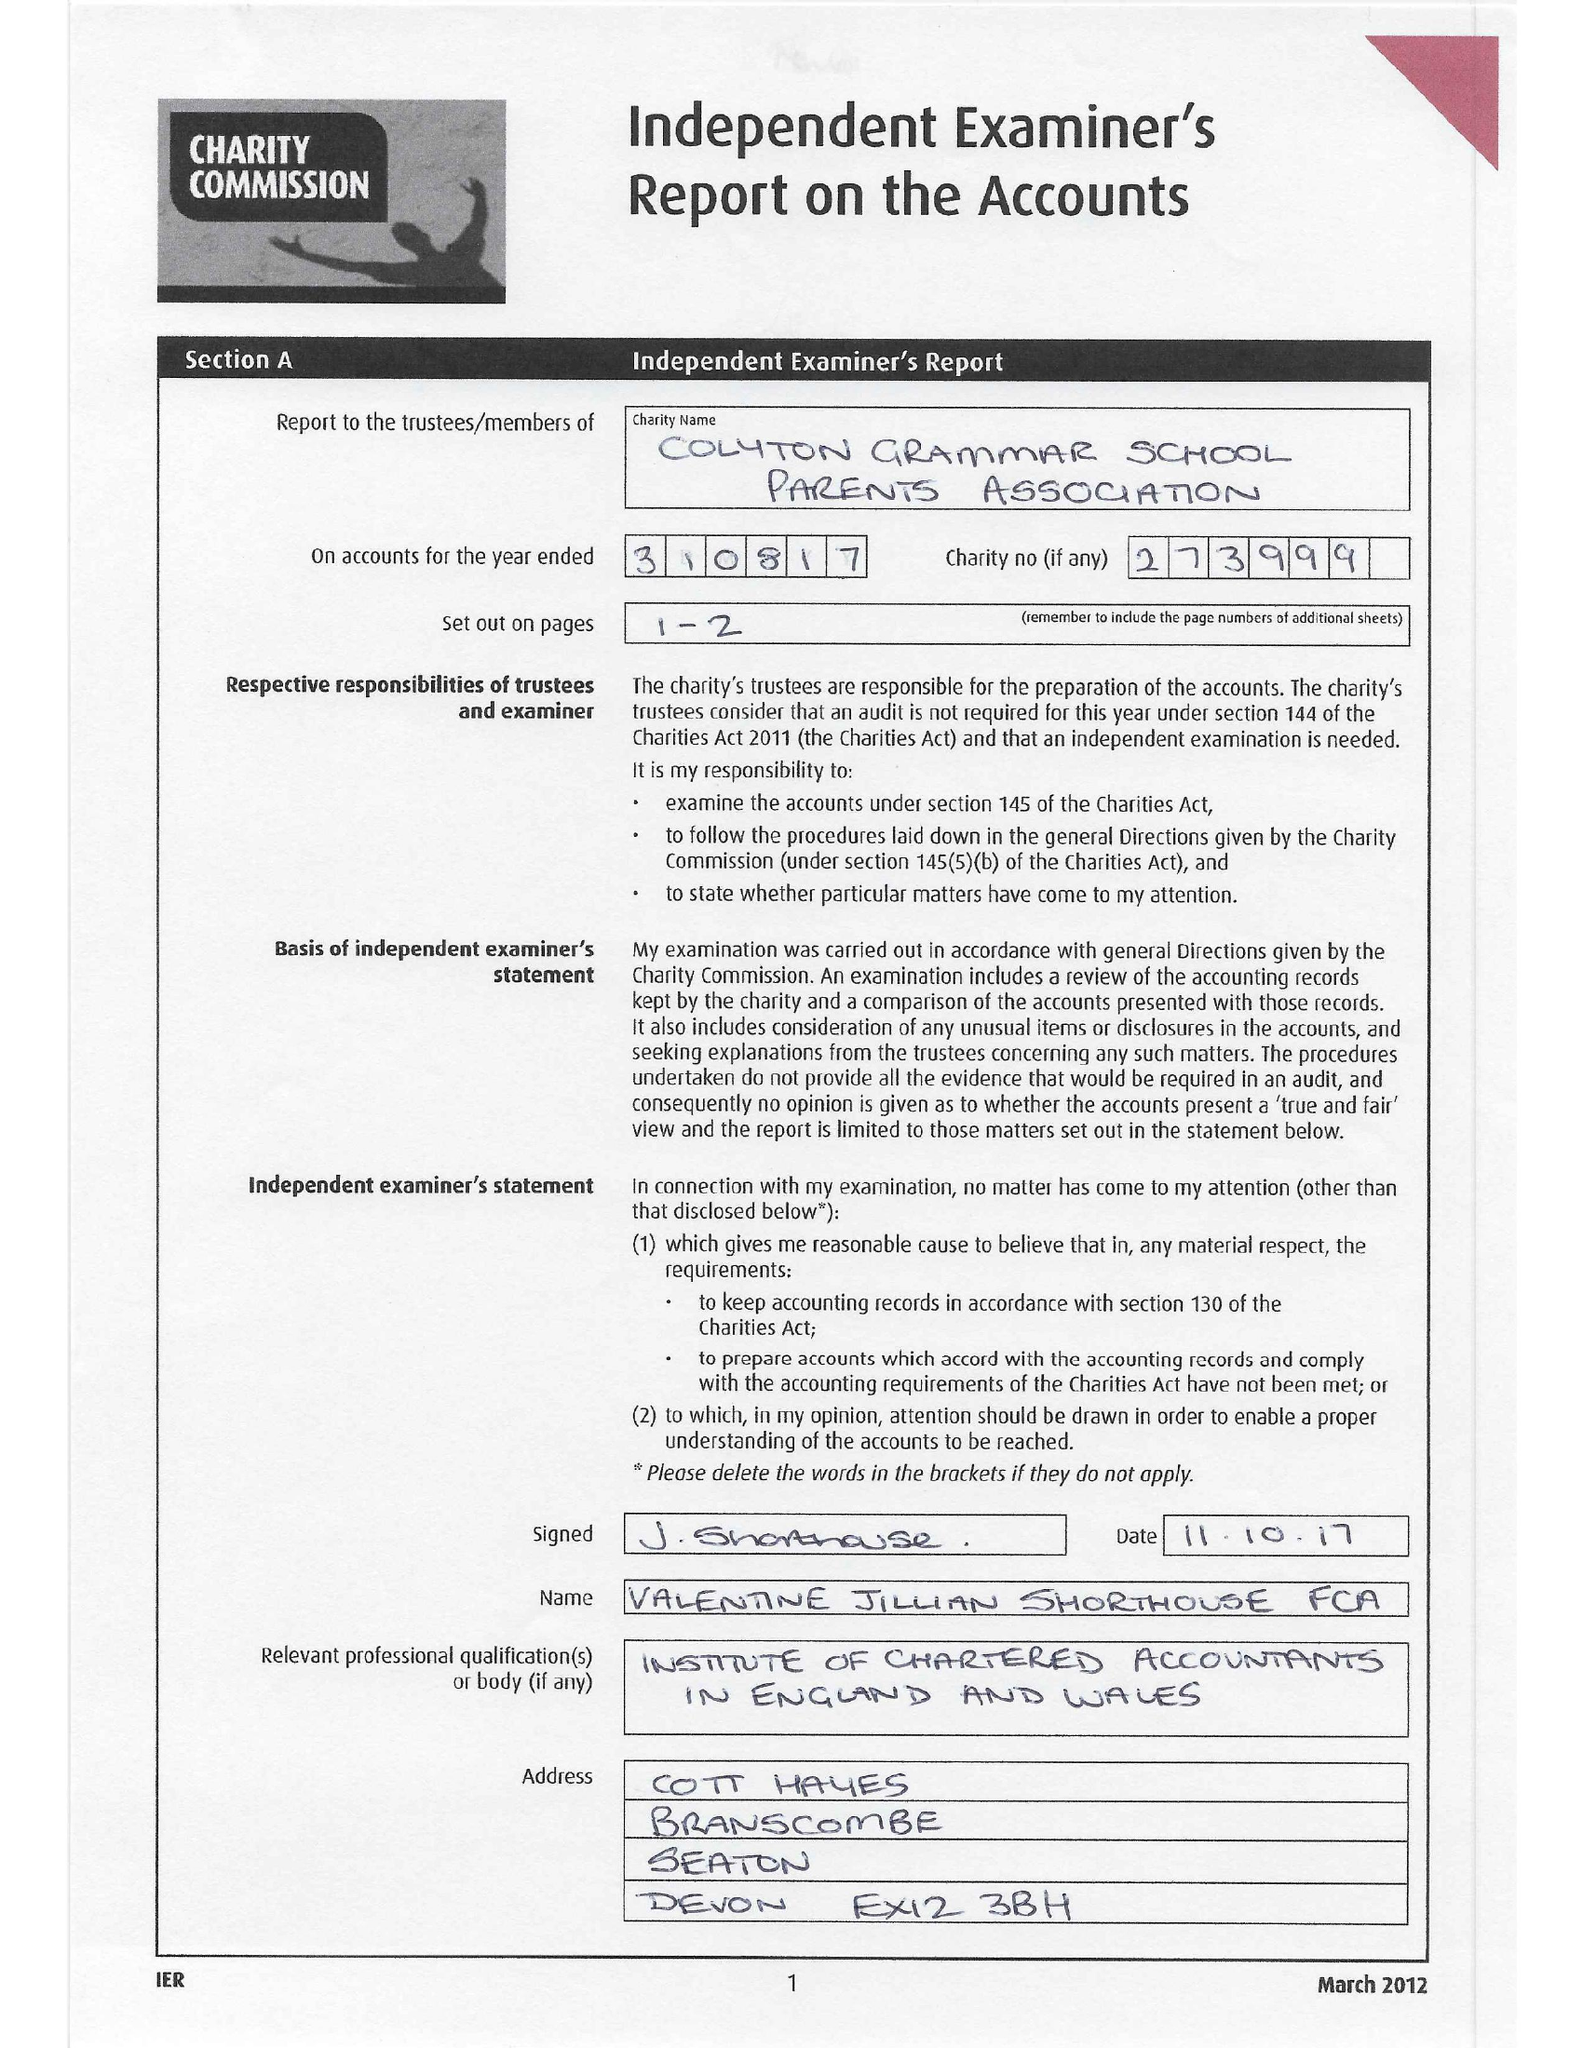What is the value for the spending_annually_in_british_pounds?
Answer the question using a single word or phrase. 34310.00 